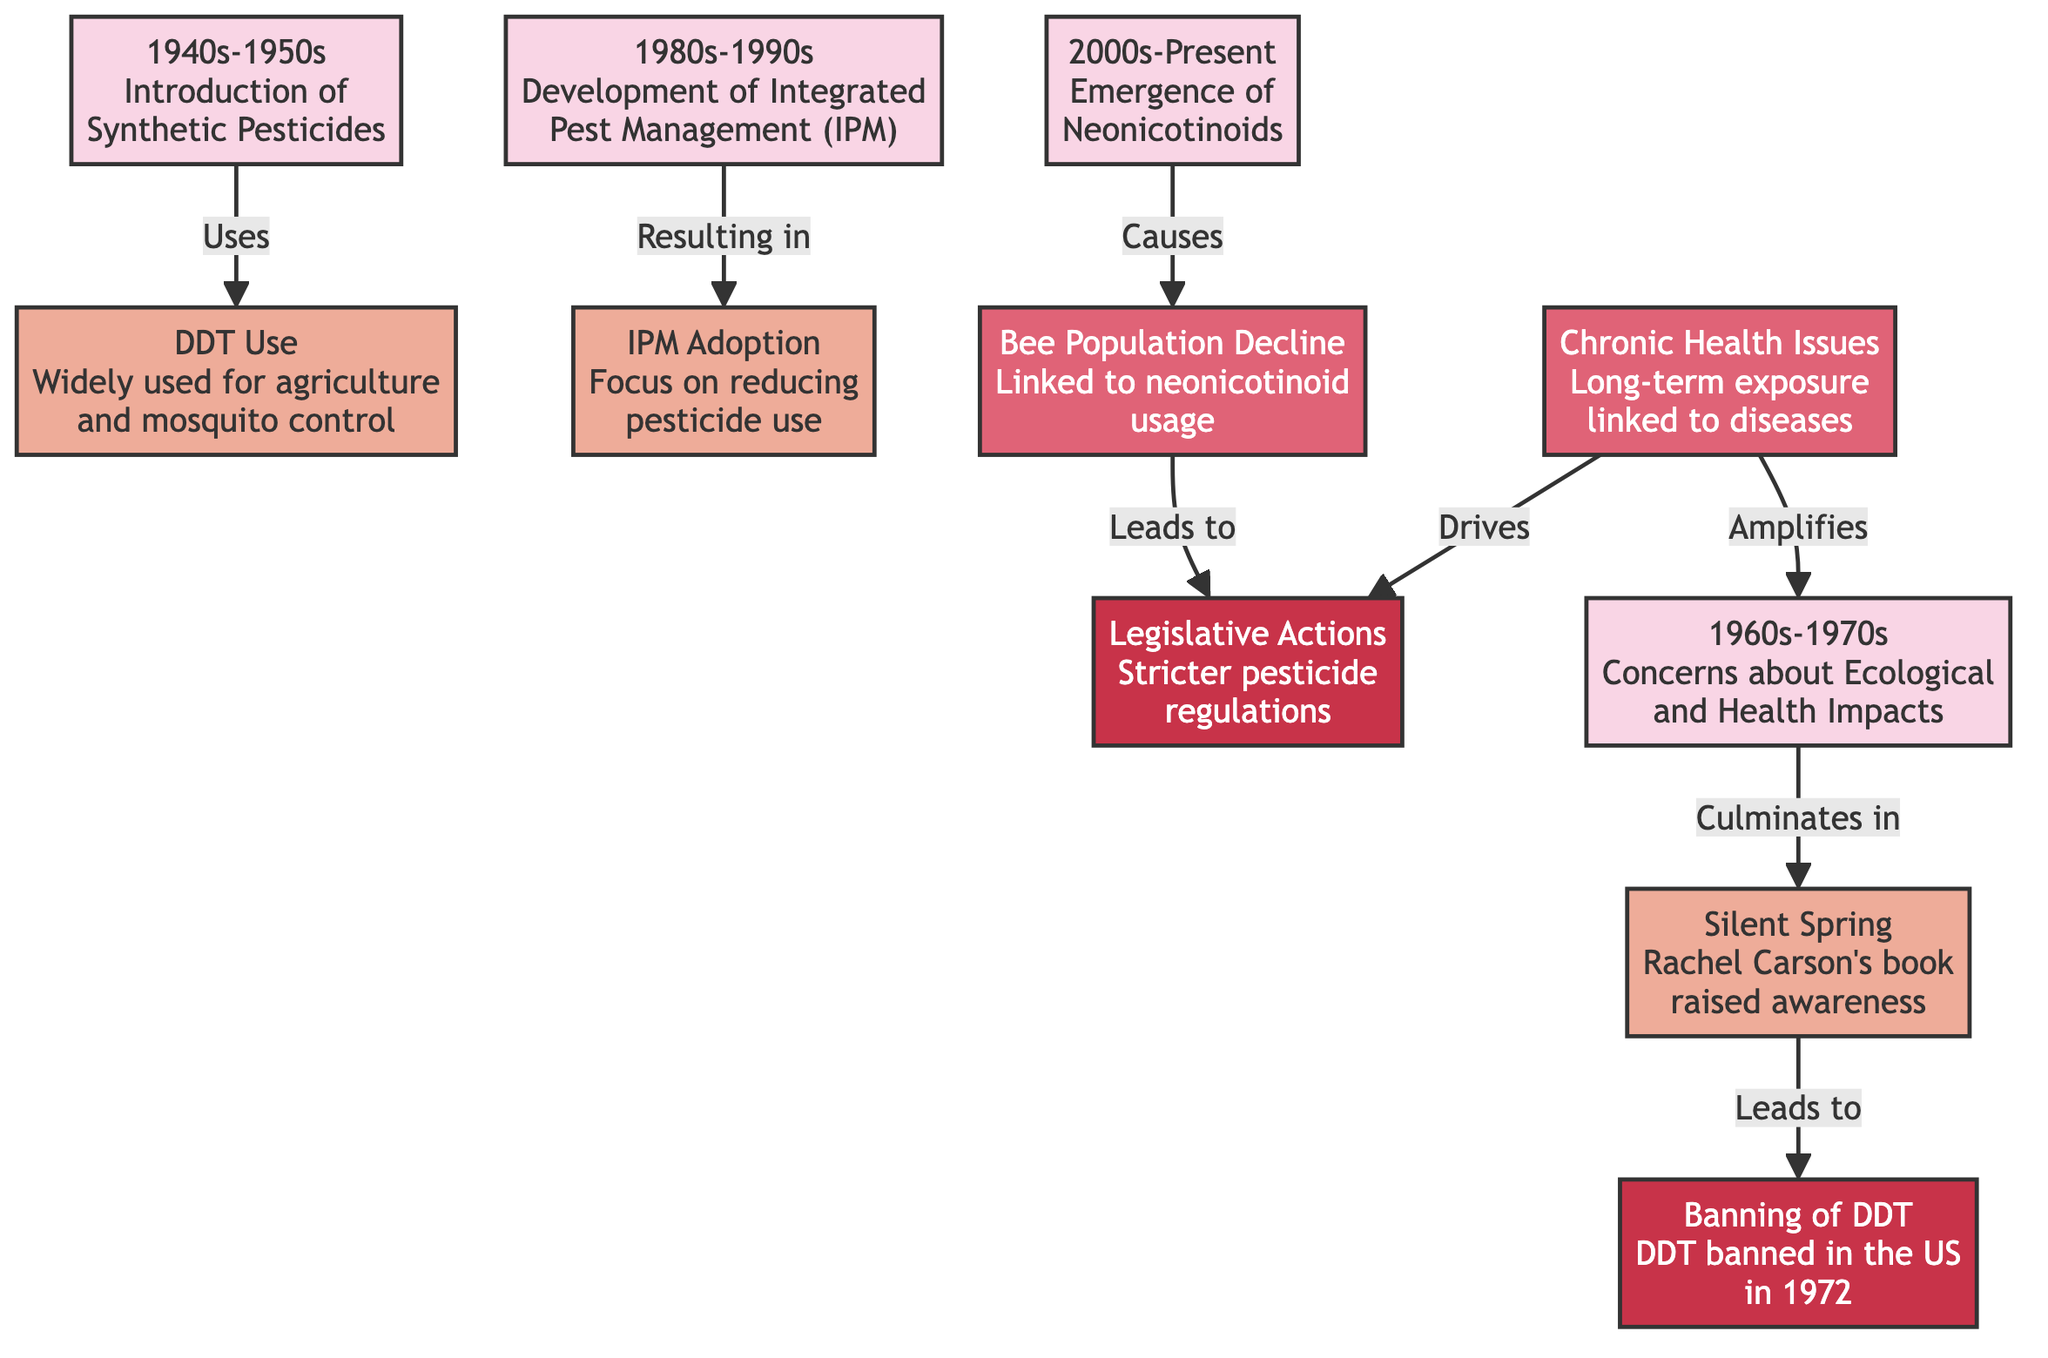What decade marks the introduction of synthetic pesticides? The diagram indicates that the introduction of synthetic pesticides occurred during the 1940s-1950s. This is shown in the first node.
Answer: 1940s-1950s What event is associated with DDT in the 1940s-1950s? The diagram links the use of DDT to the widespread agriculture and mosquito control during the 1940s-1950s. This association is described in the second node.
Answer: DDT Use Which book raised awareness about ecological and health impacts? The flowchart identifies "Silent Spring" by Rachel Carson as the book that raised awareness about ecological and health impacts during the 1960s-1970s. This information is in the fourth node.
Answer: Silent Spring What legislative action was taken in 1972? According to the diagram, DDT was banned in the US in 1972, which is represented in the fifth node.
Answer: Banning of DDT What health issue links to neonicotinoid usage? The diagram connects bee population decline to neonicotinoid usage, indicating a health impact related to pesticide use in the eighth node.
Answer: Bee Population Decline What major policy evolved during the 1980s-1990s? The development of Integrated Pest Management (IPM) is highlighted as a major policy change during the 1980s-1990s in the sixth node.
Answer: Integrated Pest Management How did chronic health issues impact pesticide regulations? The diagram suggests that chronic health issues, highlighted as a long-term exposure concern, drove stricter pesticide regulations, showing a cause-and-effect relationship. Hence, chronic health issues are interlinked with legislative actions.
Answer: Drives What two major impacts were amplified by chronic health issues? The diagram shows that chronic health issues amplify concerns about ecological impacts and lead to stricter pesticide regulations, effectively connecting these concepts together.
Answer: Amplifies What is the sequence of events from DDT use to its ban? The flow of the diagram shows that DDT usage led to concerns about ecological and health impacts which culminated in Rachel Carson's "Silent Spring", leading eventually to the ban in 1972. This sequence captures the direct relationship among these events.
Answer: DDT Use to Banning of DDT 